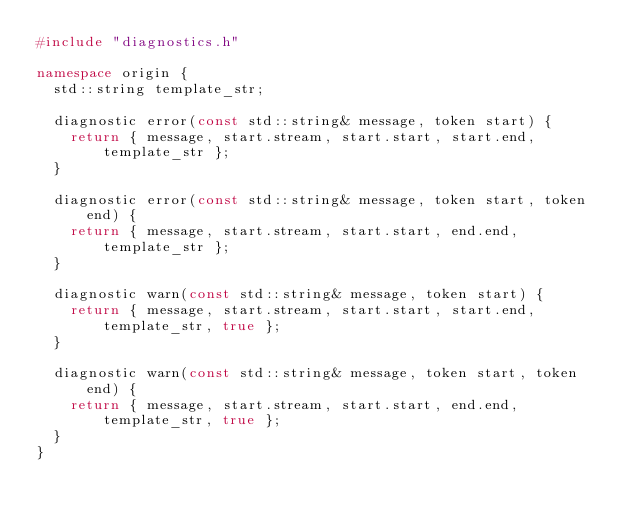<code> <loc_0><loc_0><loc_500><loc_500><_C++_>#include "diagnostics.h"

namespace origin {
	std::string template_str;

	diagnostic error(const std::string& message, token start) {
		return { message, start.stream, start.start, start.end, template_str };
	}

	diagnostic error(const std::string& message, token start, token end) {
		return { message, start.stream, start.start, end.end, template_str };
	}

	diagnostic warn(const std::string& message, token start) {
		return { message, start.stream, start.start, start.end, template_str, true };
	}

	diagnostic warn(const std::string& message, token start, token end) {
		return { message, start.stream, start.start, end.end, template_str, true };
	}
}</code> 